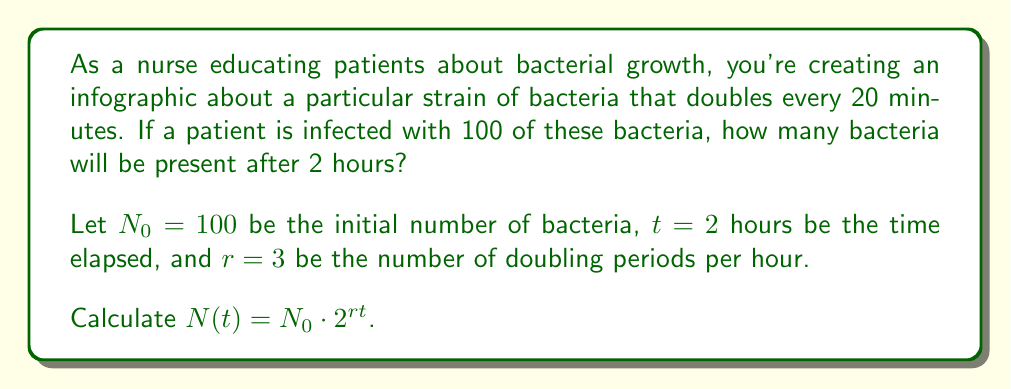Solve this math problem. To solve this problem, we'll use the exponential growth formula:

$$N(t) = N_0 \cdot 2^{rt}$$

Where:
- $N(t)$ is the number of bacteria after time $t$
- $N_0$ is the initial number of bacteria
- $2$ is the growth factor (doubling)
- $r$ is the rate of doubling periods per hour
- $t$ is the time elapsed in hours

Given:
- $N_0 = 100$ (initial bacteria)
- $t = 2$ hours
- Doubling time = 20 minutes

First, calculate $r$:
In 1 hour, there are 3 doubling periods (60 minutes / 20 minutes per doubling).
So, $r = 3$ doubling periods per hour.

Now, let's substitute the values into the formula:

$$N(2) = 100 \cdot 2^{3 \cdot 2}$$

Simplify the exponent:
$$N(2) = 100 \cdot 2^6$$

Calculate $2^6$:
$$N(2) = 100 \cdot 64$$

Multiply:
$$N(2) = 6400$$

Therefore, after 2 hours, there will be 6400 bacteria.
Answer: $6400$ bacteria 